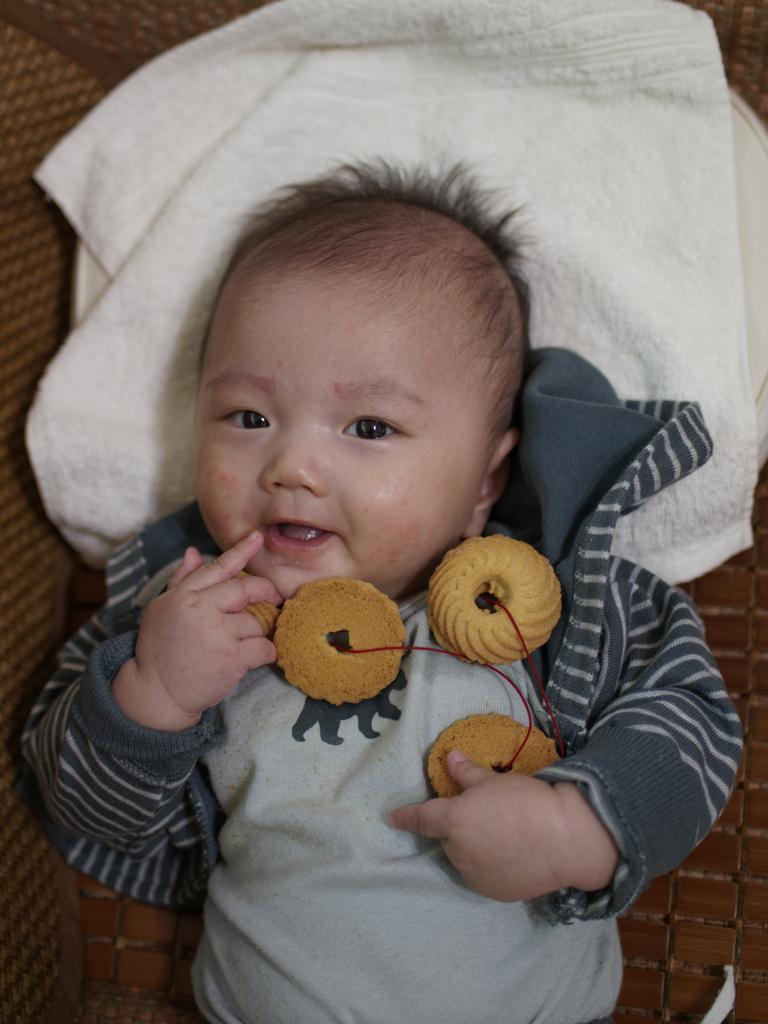Please provide a concise description of this image. In this image we can see a baby. Behind the baby there is a cloth. Also we can see cookies on the baby. 